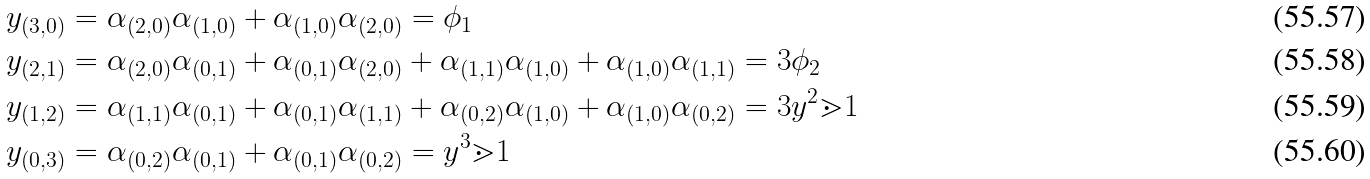Convert formula to latex. <formula><loc_0><loc_0><loc_500><loc_500>y _ { ( 3 , 0 ) } & = \alpha _ { ( 2 , 0 ) } \alpha _ { ( 1 , 0 ) } + \alpha _ { ( 1 , 0 ) } \alpha _ { ( 2 , 0 ) } = \phi _ { 1 } \\ y _ { ( 2 , 1 ) } & = \alpha _ { ( 2 , 0 ) } \alpha _ { ( 0 , 1 ) } + \alpha _ { ( 0 , 1 ) } \alpha _ { ( 2 , 0 ) } + \alpha _ { ( 1 , 1 ) } \alpha _ { ( 1 , 0 ) } + \alpha _ { ( 1 , 0 ) } \alpha _ { ( 1 , 1 ) } = 3 \phi _ { 2 } \\ y _ { ( 1 , 2 ) } & = \alpha _ { ( 1 , 1 ) } \alpha _ { ( 0 , 1 ) } + \alpha _ { ( 0 , 1 ) } \alpha _ { ( 1 , 1 ) } + \alpha _ { ( 0 , 2 ) } \alpha _ { ( 1 , 0 ) } + \alpha _ { ( 1 , 0 ) } \alpha _ { ( 0 , 2 ) } = 3 y ^ { 2 } \mathbb { m } { 1 } \\ y _ { ( 0 , 3 ) } & = \alpha _ { ( 0 , 2 ) } \alpha _ { ( 0 , 1 ) } + \alpha _ { ( 0 , 1 ) } \alpha _ { ( 0 , 2 ) } = y ^ { 3 } \mathbb { m } { 1 }</formula> 